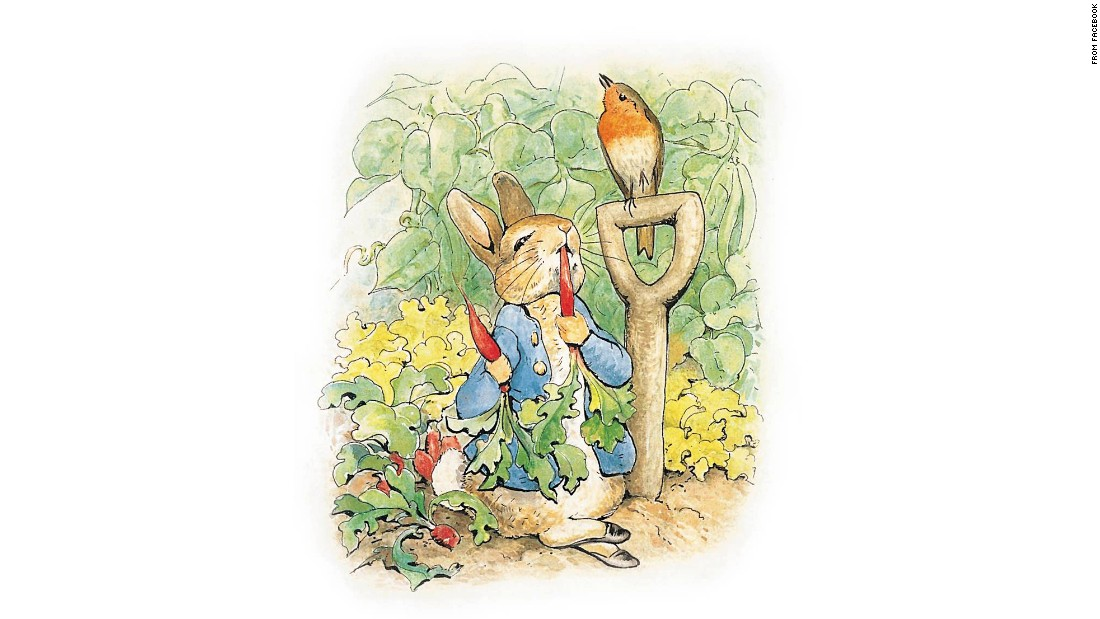Considering the growth stage of the vegetables and the presence of flowers, what time of year could this scene be depicting? The delightful illustration, showcasing vegetables at their peak and vibrant flowers in full bloom, aptly suggests it is late spring or early summer. During this time, the warmer temperatures and increased daylight support the flourishing of plants, as evidenced by the lush greenery and the mature radishes ready for harvest. Such conditions not only promote plant growth but also attract a variety of wildlife, enriching the garden’s ecosystem. 